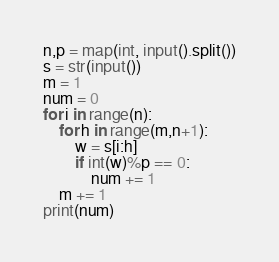<code> <loc_0><loc_0><loc_500><loc_500><_Python_>n,p = map(int, input().split())
s = str(input())
m = 1
num = 0
for i in range(n):
    for h in range(m,n+1):
        w = s[i:h]
        if int(w)%p == 0:
            num += 1
    m += 1
print(num)</code> 